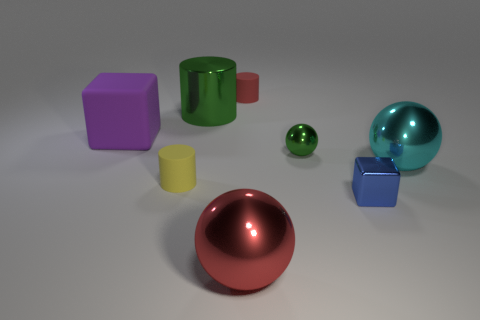What number of metal things are tiny blue blocks or large purple things?
Your answer should be compact. 1. There is a big metallic ball in front of the sphere to the right of the metal cube; what color is it?
Make the answer very short. Red. Are the large cyan sphere and the red object behind the big purple rubber block made of the same material?
Your answer should be very brief. No. There is a ball that is in front of the block right of the big object that is in front of the cyan thing; what is its color?
Your answer should be compact. Red. Is the number of large purple blocks greater than the number of tiny rubber cylinders?
Make the answer very short. No. How many small things are both right of the yellow object and in front of the big cyan metallic object?
Provide a succinct answer. 1. There is a cylinder behind the big green shiny object; how many spheres are in front of it?
Offer a very short reply. 3. Do the ball in front of the cyan metallic thing and the red object that is behind the yellow cylinder have the same size?
Your response must be concise. No. How many matte cylinders are there?
Offer a terse response. 2. How many small cylinders are the same material as the purple object?
Offer a very short reply. 2. 